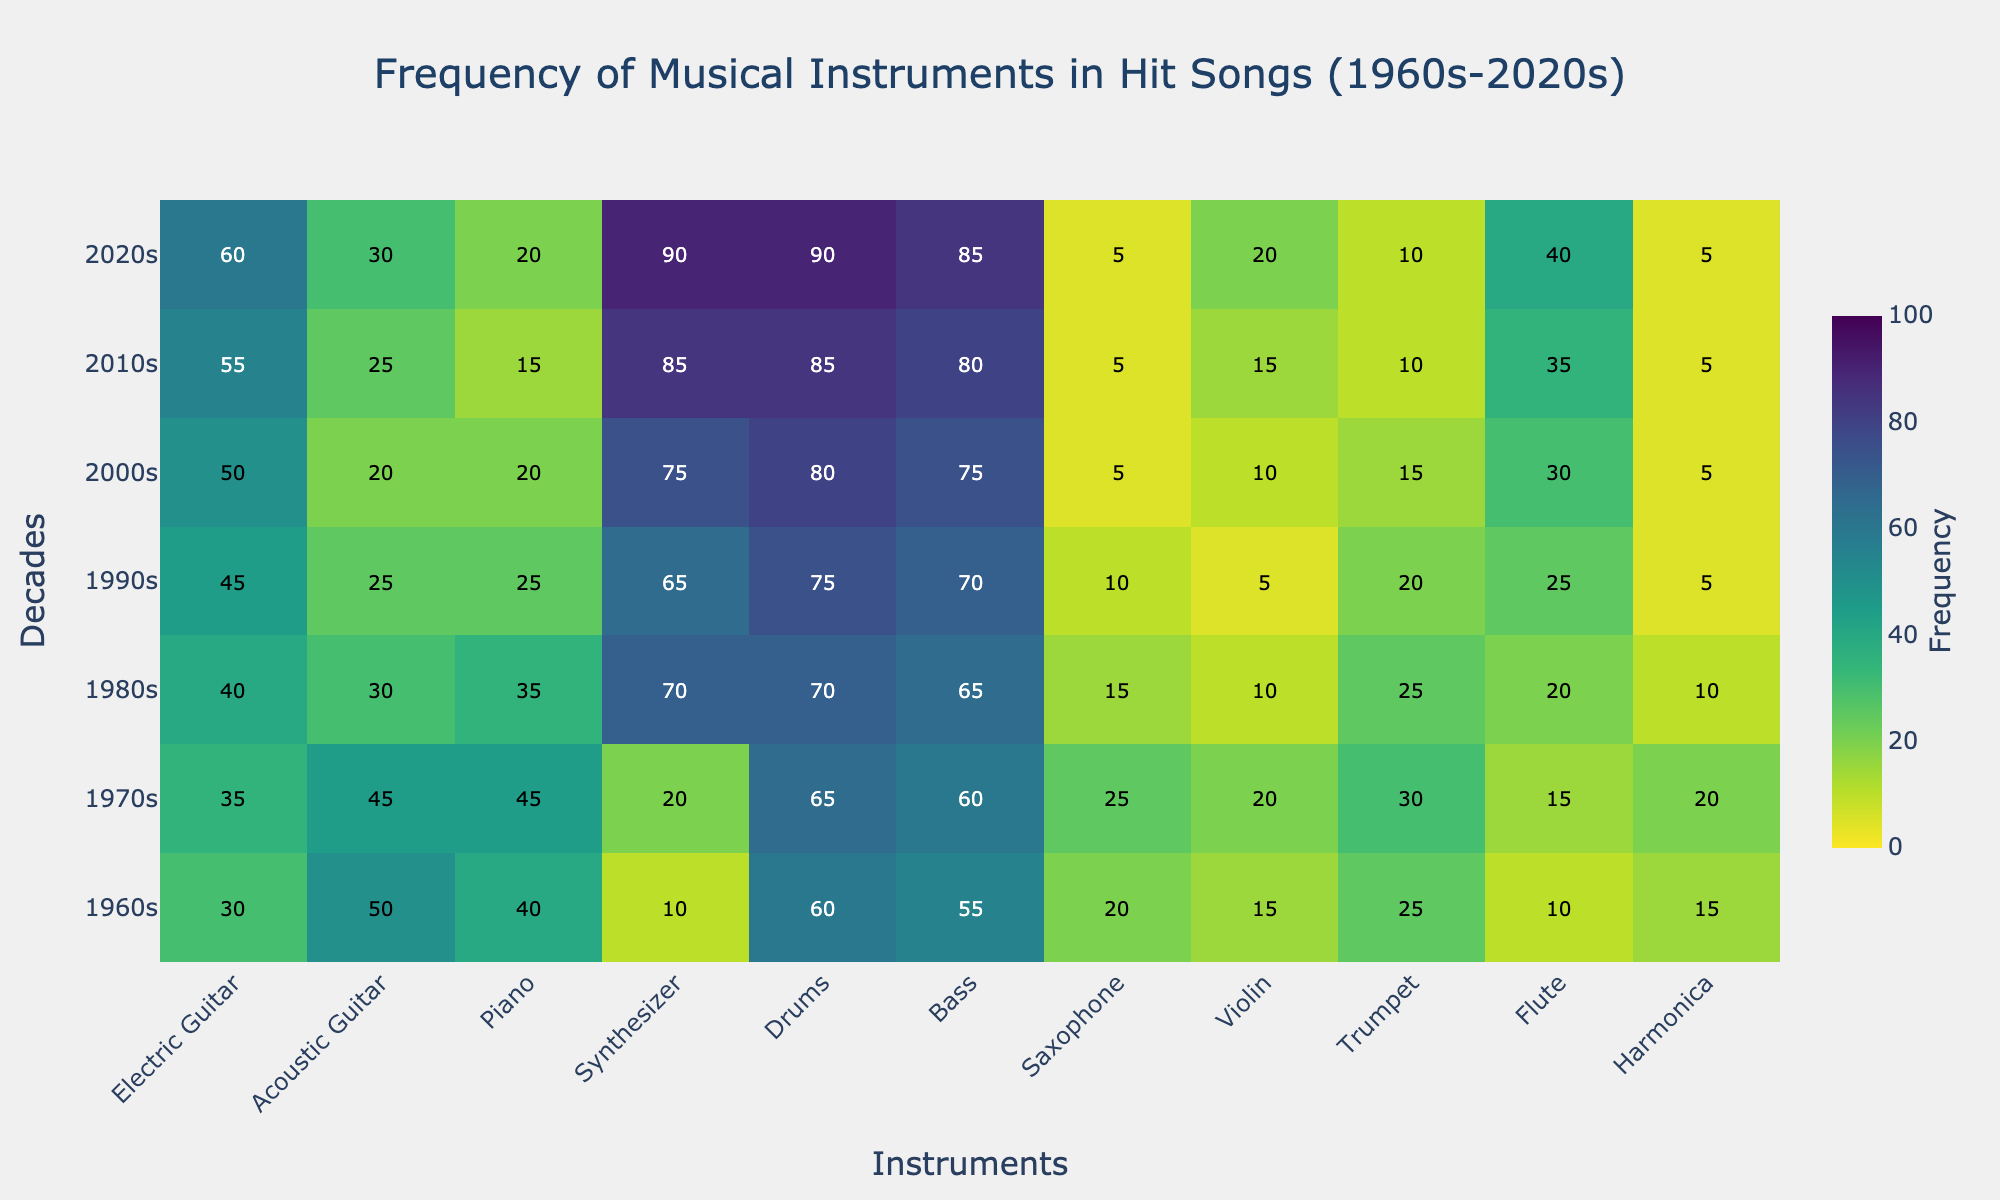How frequently was the synthesizer used in the 1980s? Look at the cell where the 1980s row intersects with the synthesizer column. The frequency displayed is 70.
Answer: 70 During which decade did the electric guitar reach its highest frequency? Scan the electric guitar column from top to bottom to find the highest value, which is in the 2020s.
Answer: 2020s What is the average frequency of the drums across all decades? Add the frequencies of the drums for all decades (60 + 65 + 70 + 75 + 80 + 85 + 90) which equals 525, then divide by the number of decades (7). The result is 75.
Answer: 75 In which decade did the acoustic guitar see the most significant decrease in usage compared to the previous decade? Compare the difference in acoustic guitar frequency between consecutive decades. The largest decrease is between the 1970s (45) to 1980s (30), which is 15.
Answer: 1980s Which instrument had a consistent increase in usage from the 1960s to the 2020s? Scan each instrument column to find which one consistently increases without any drops. The synthesizer consistently increases.
Answer: Synthesizer Compare the frequency of the piano in the 1960s and 2010s. Which decade had a higher frequency, and by how much? Refer to the cells in the piano column for the 1960s (40) and 2010s (15). The 1960s had a higher frequency. The difference is 40 - 15 = 25.
Answer: 1960s, 25 Which instrument had the highest frequency in the 2000s? Look at the 2000s row and find the highest value amongst all instruments. The highest value is 80, found in the drums column.
Answer: Drums What is the sum of frequencies for the trumpet in the 1990s and 2000s? Add the frequencies of the trumpet for the 1990s (20) and 2000s (15). The sum is 20 + 15 = 35.
Answer: 35 Which decade shows the highest frequency for the violin, and what is the value? Scan the violin column and find the highest value and its corresponding decade. The highest value is 20 in the 2020s.
Answer: 2020s, 20 How did the frequency of the saxophone change from the 1960s to the 2020s? Compare the values in the saxophone column for the 1960s (20) and 2020s (5). The frequency decreased by 20 - 5 = 15.
Answer: Decreased by 15 